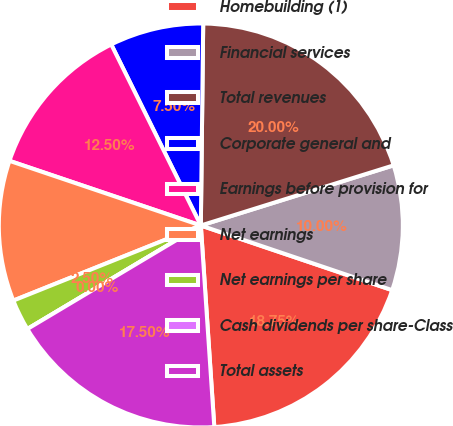Convert chart. <chart><loc_0><loc_0><loc_500><loc_500><pie_chart><fcel>Homebuilding (1)<fcel>Financial services<fcel>Total revenues<fcel>Corporate general and<fcel>Earnings before provision for<fcel>Net earnings<fcel>Net earnings per share<fcel>Cash dividends per share-Class<fcel>Total assets<nl><fcel>18.75%<fcel>10.0%<fcel>20.0%<fcel>7.5%<fcel>12.5%<fcel>11.25%<fcel>2.5%<fcel>0.0%<fcel>17.5%<nl></chart> 